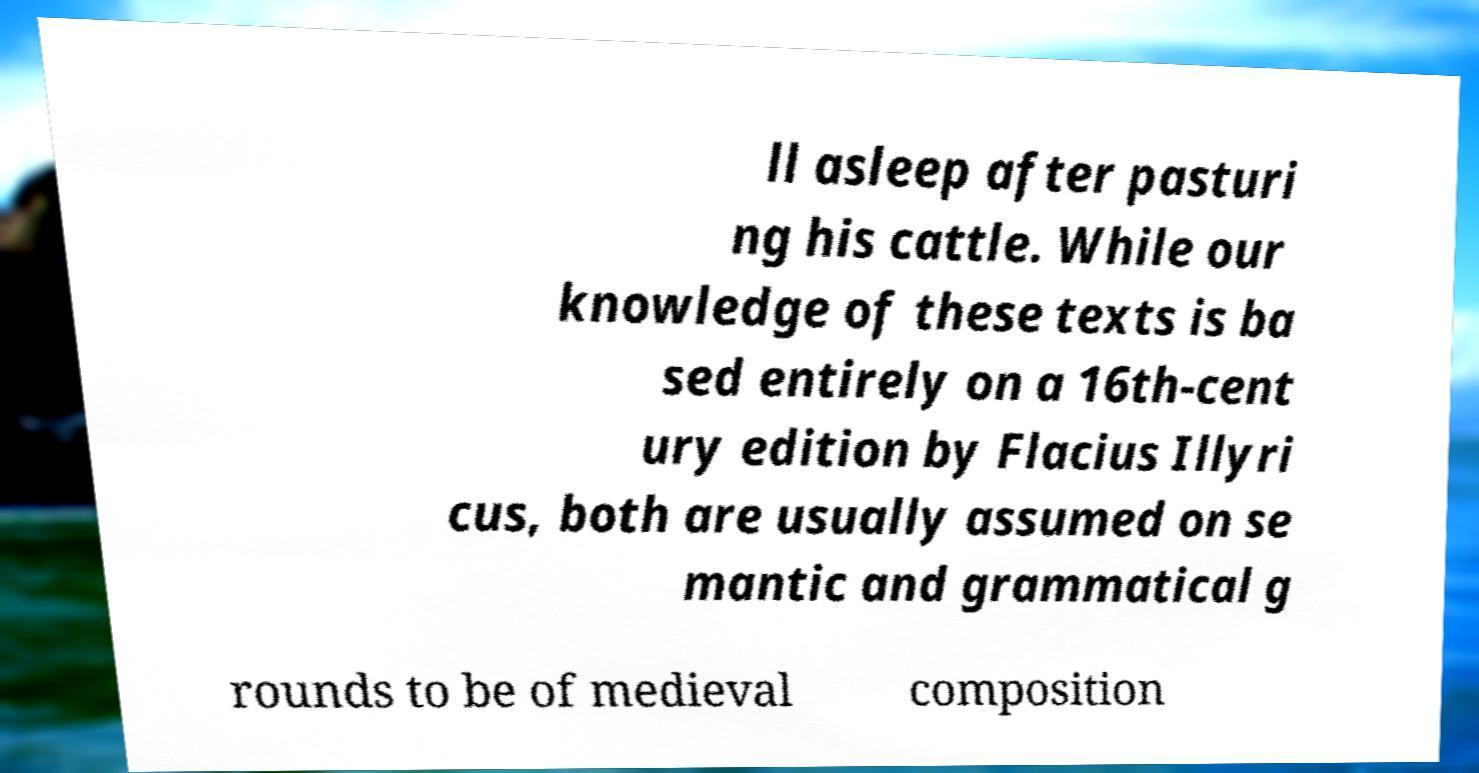Please read and relay the text visible in this image. What does it say? ll asleep after pasturi ng his cattle. While our knowledge of these texts is ba sed entirely on a 16th-cent ury edition by Flacius Illyri cus, both are usually assumed on se mantic and grammatical g rounds to be of medieval composition 